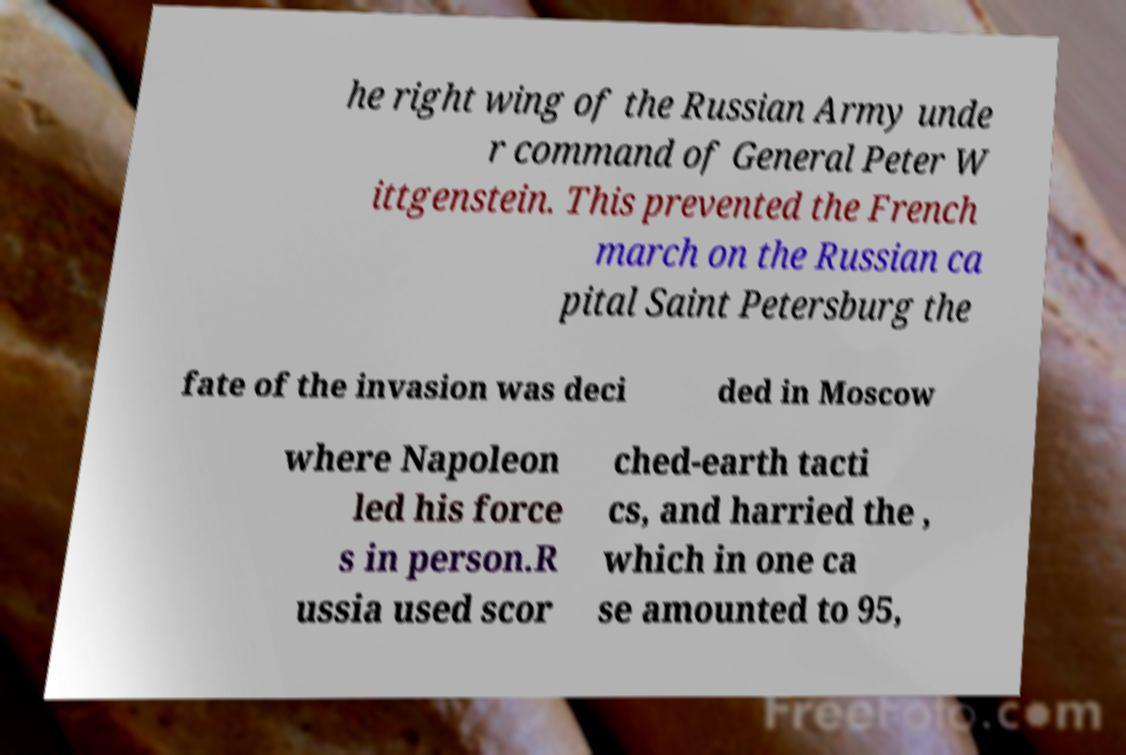Can you read and provide the text displayed in the image?This photo seems to have some interesting text. Can you extract and type it out for me? he right wing of the Russian Army unde r command of General Peter W ittgenstein. This prevented the French march on the Russian ca pital Saint Petersburg the fate of the invasion was deci ded in Moscow where Napoleon led his force s in person.R ussia used scor ched-earth tacti cs, and harried the , which in one ca se amounted to 95, 